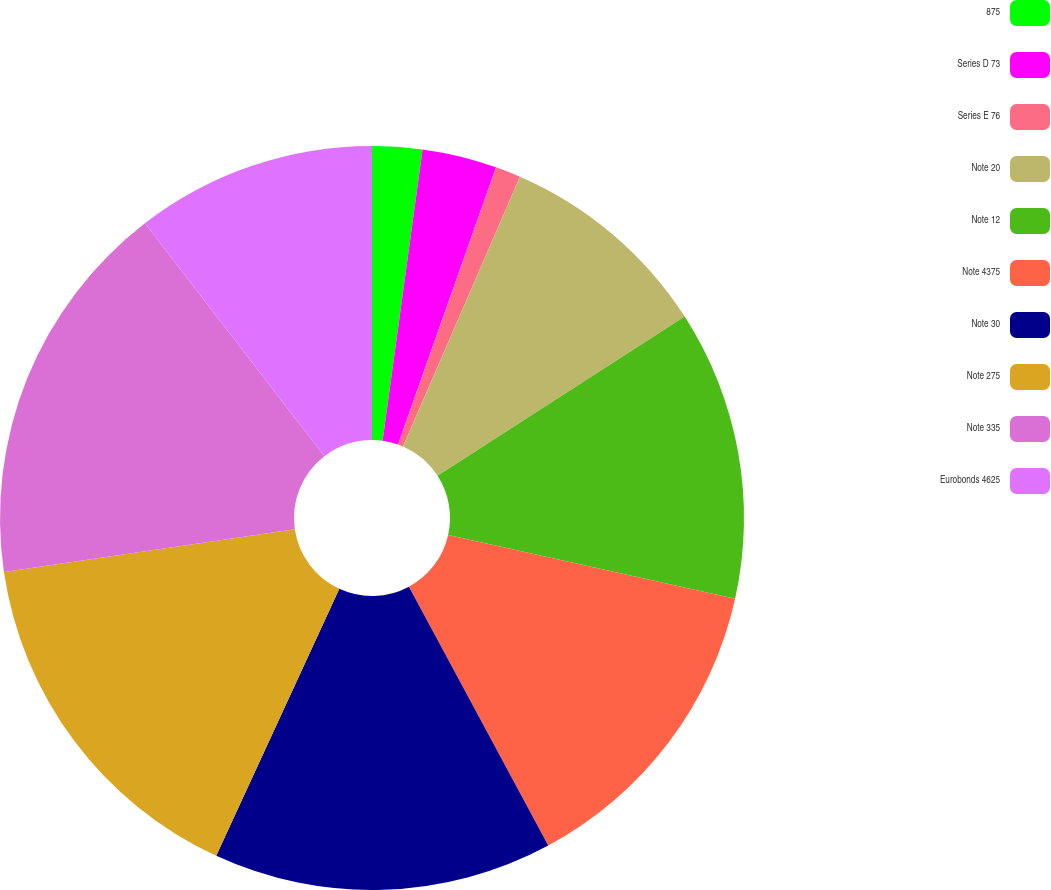Convert chart to OTSL. <chart><loc_0><loc_0><loc_500><loc_500><pie_chart><fcel>875<fcel>Series D 73<fcel>Series E 76<fcel>Note 20<fcel>Note 12<fcel>Note 4375<fcel>Note 30<fcel>Note 275<fcel>Note 335<fcel>Eurobonds 4625<nl><fcel>2.17%<fcel>3.24%<fcel>1.1%<fcel>9.38%<fcel>12.59%<fcel>13.66%<fcel>14.73%<fcel>15.8%<fcel>16.87%<fcel>10.45%<nl></chart> 